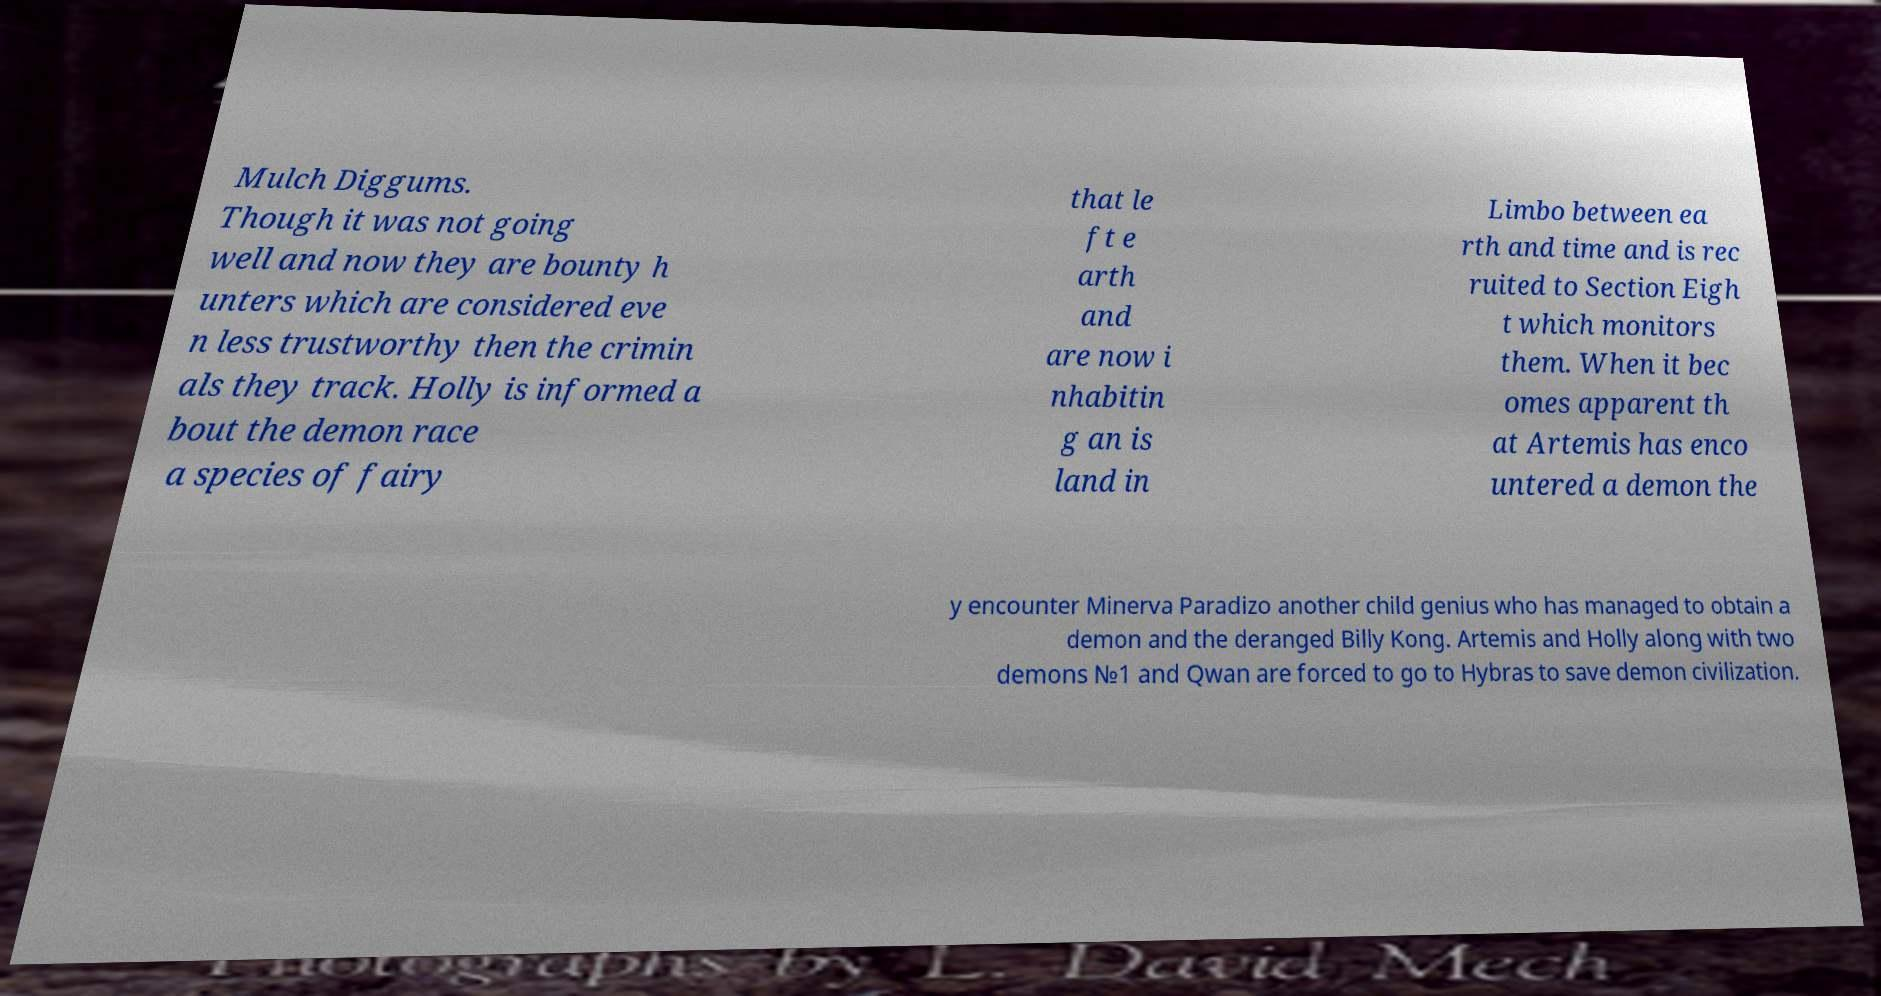For documentation purposes, I need the text within this image transcribed. Could you provide that? Mulch Diggums. Though it was not going well and now they are bounty h unters which are considered eve n less trustworthy then the crimin als they track. Holly is informed a bout the demon race a species of fairy that le ft e arth and are now i nhabitin g an is land in Limbo between ea rth and time and is rec ruited to Section Eigh t which monitors them. When it bec omes apparent th at Artemis has enco untered a demon the y encounter Minerva Paradizo another child genius who has managed to obtain a demon and the deranged Billy Kong. Artemis and Holly along with two demons №1 and Qwan are forced to go to Hybras to save demon civilization. 